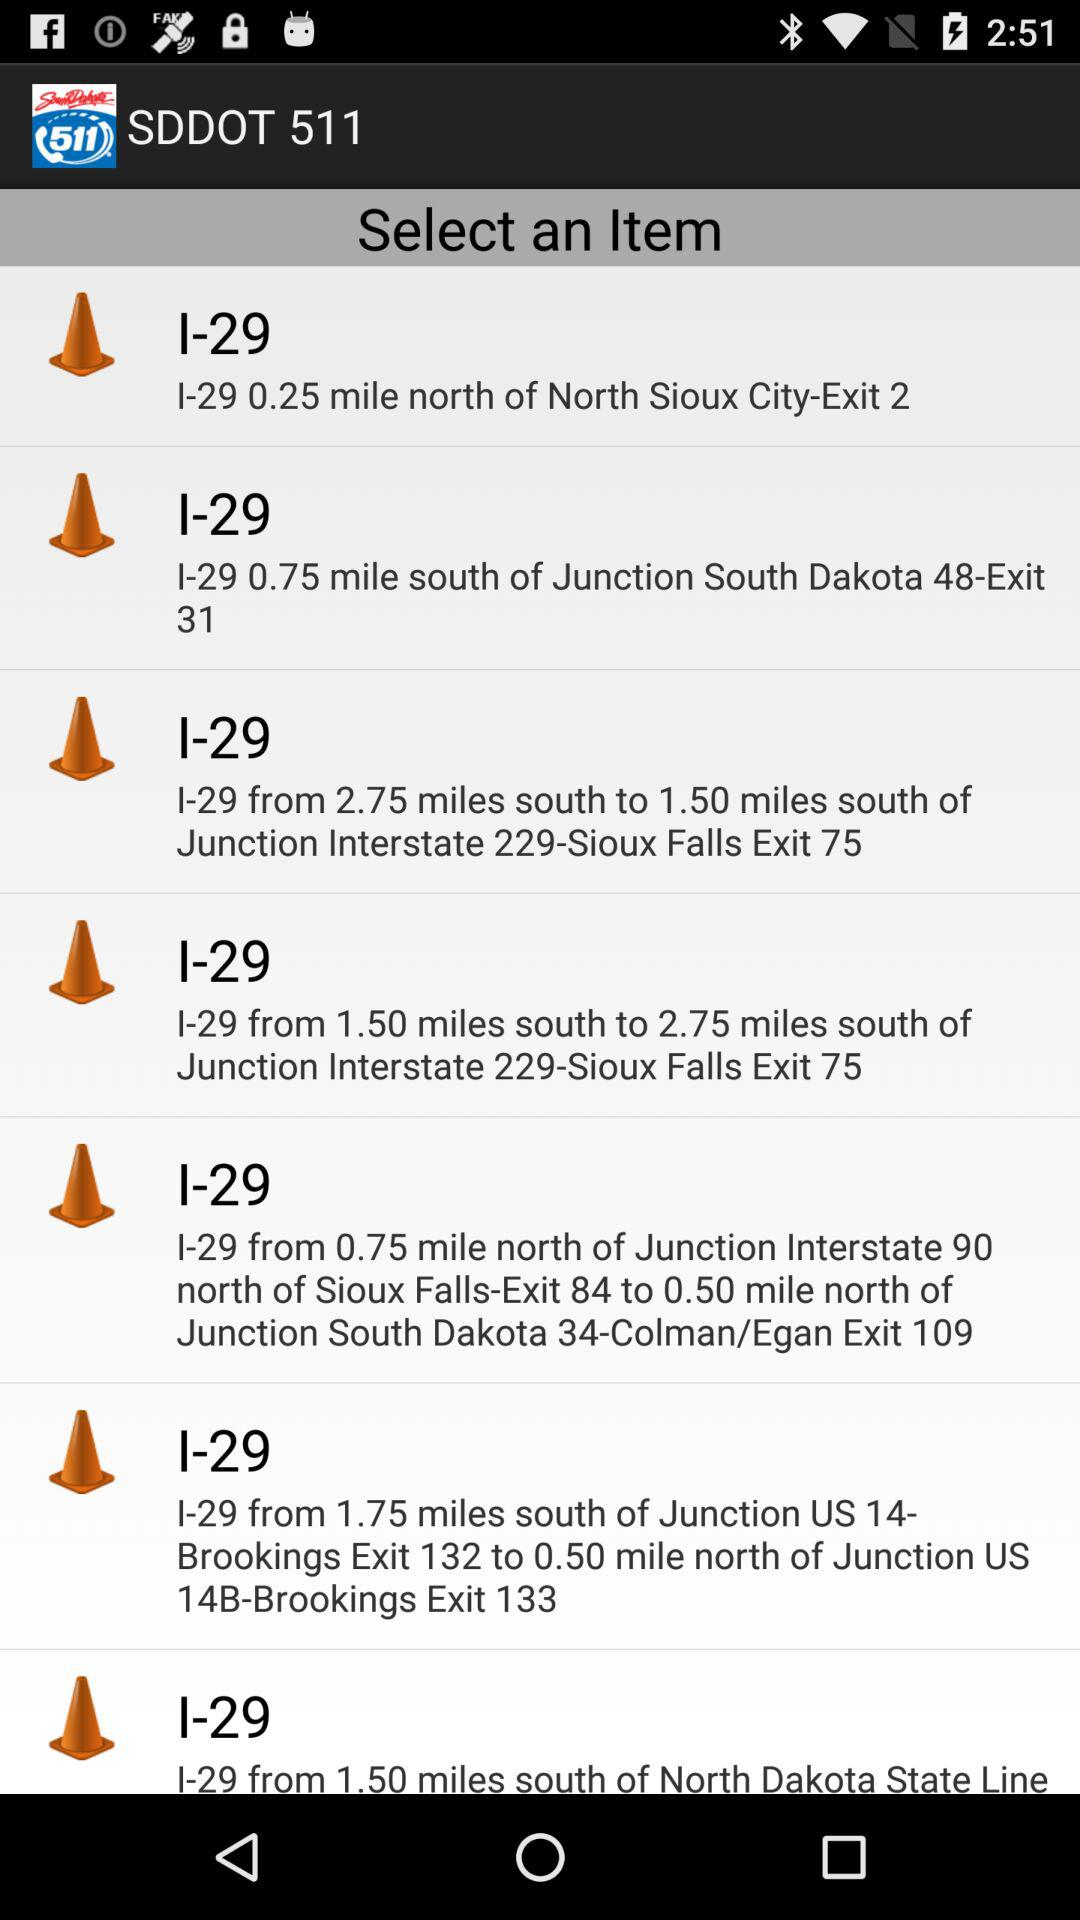I-29 is how many miles from south to 1.50 miles south of junction interstate 229? I-29 is 2.75 miles from south to 1.50 miles south of junction interstate 229. 